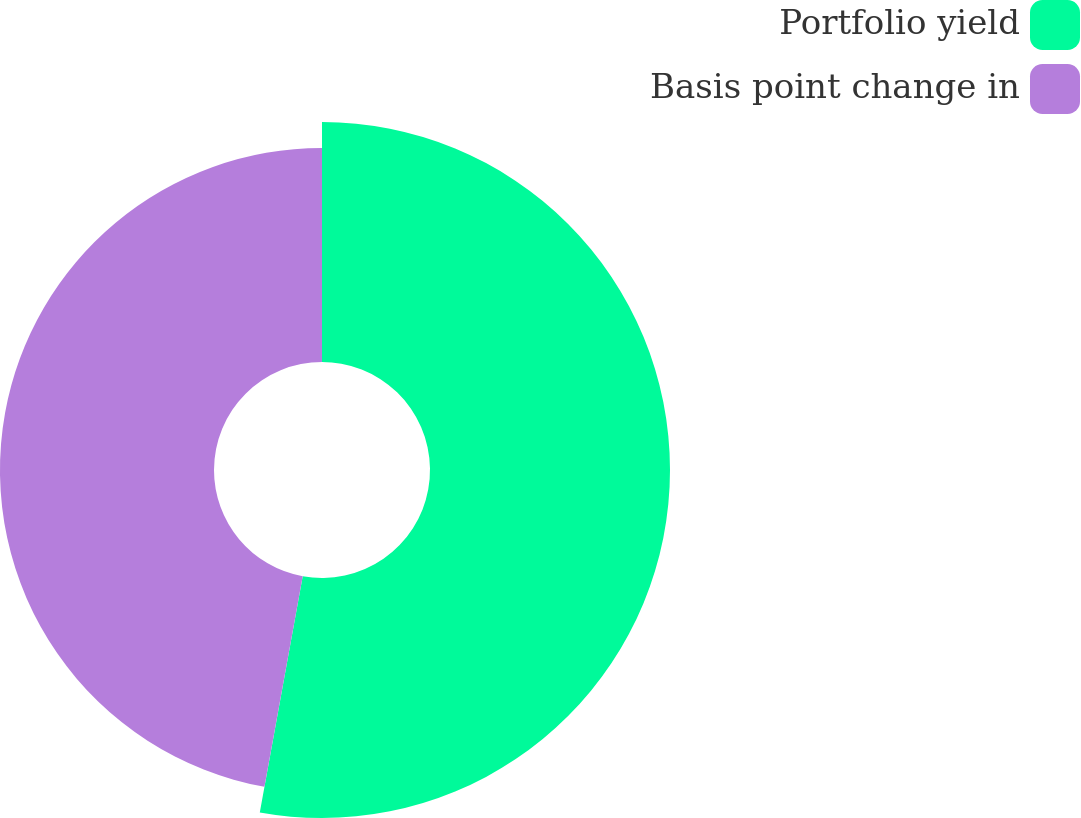<chart> <loc_0><loc_0><loc_500><loc_500><pie_chart><fcel>Portfolio yield<fcel>Basis point change in<nl><fcel>52.86%<fcel>47.14%<nl></chart> 